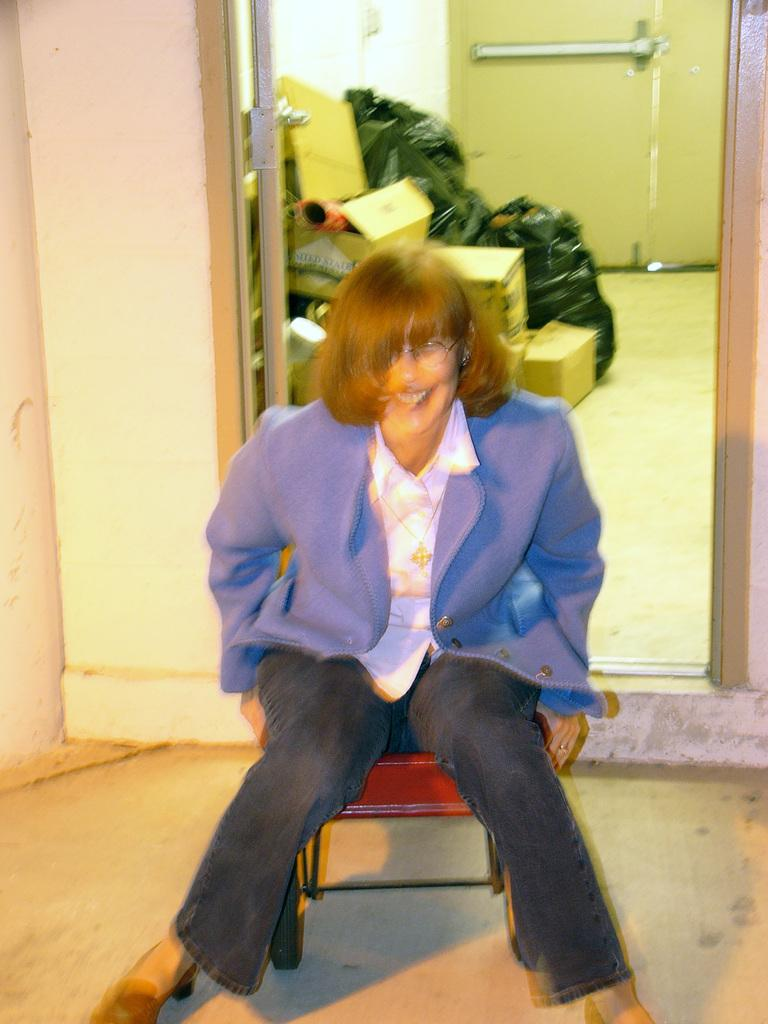Who is the main subject in the image? There is a woman in the image. What is the woman doing in the image? The woman is sitting on a chair. What can be seen in the background of the image? There are covers and boxes in the background of the image. Is there any architectural feature visible in the image? Yes, there is a door in the background of the image. What type of parent is the woman in the image? There is no information about the woman being a parent in the image. --- Facts: 1. There is a car in the image. 2. The car is red. 3. The car has four wheels. 4. The car has a sunroof. 5. The car is parked on the street. Absurd Topics: bicycle, parrot Conversation: What is the main subject in the image? There is a car in the image. What color is the car? The car is red. How many wheels does the car have? The car has four wheels. What special feature does the car have? The car has a sunroof. Where is the car located in the image? The car is parked on the street. Reasoning: Let's think step by step in order to produce the conversation. We start by identifying the main subject of the image, which is the car. Next, we describe specific features of the car, such as its color, the number of wheels it has, and any special features it may have. Then, we observe the car's location in the image, which is parked on the street. We ensure that each question can be answered definitively with the information given. Absurd Question/Answer: Can you see a parrot sitting on the car's sunroof in the image? There is no parrot present in the image. --- Facts: 1. There is a group of people in the image. 2. The people are wearing hats. 3. The people are holding hands. 4. The people are standing in a circle. 5. The people are smiling. Absurd Topics: elephant, trampoline Conversation: How many people are in the image? There is a group of people in the image. What are the people wearing on their heads? The people are wearing hats. What are the people doing with their hands? The people are holding hands. How are the people positioned in the image? The people are standing in a circle. What expressions do the people have on their faces? The people are smiling. Reasoning: Let's think step by step in order to produce the conversation. We start by identifying the main subjects of the image, which is the group of people. Next, we describe specific features of the people, such 